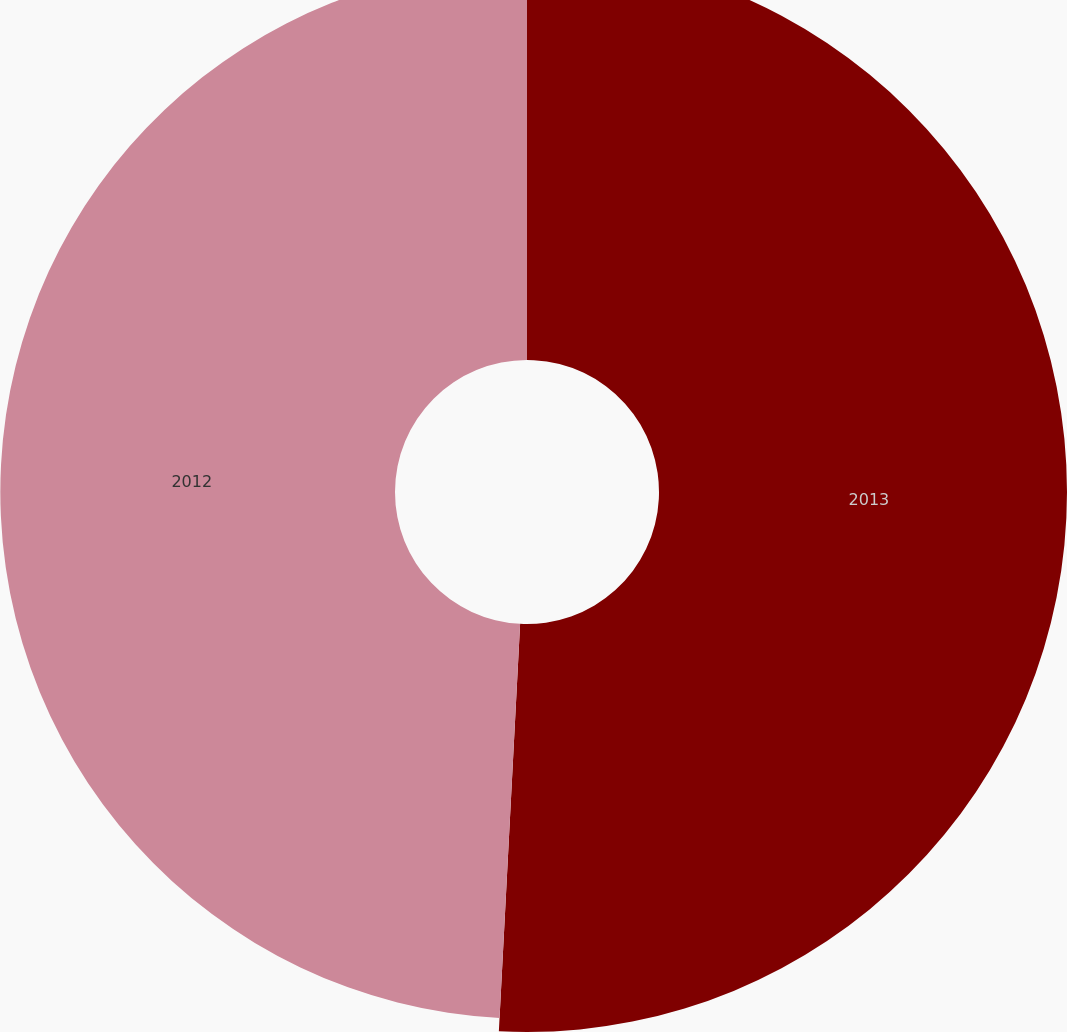Convert chart. <chart><loc_0><loc_0><loc_500><loc_500><pie_chart><fcel>2013<fcel>2012<nl><fcel>50.83%<fcel>49.17%<nl></chart> 